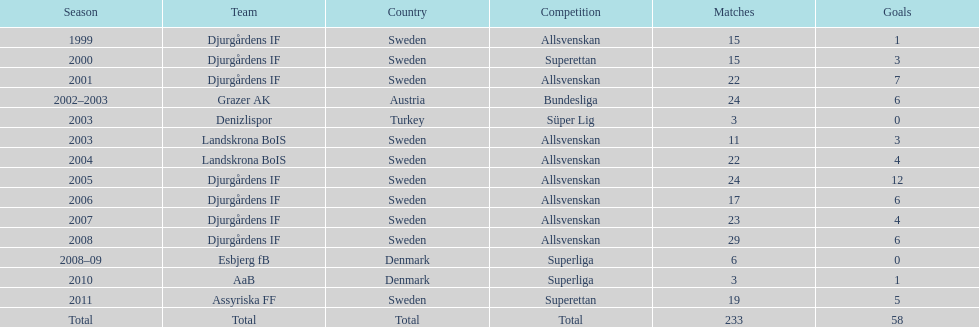How many total goals has jones kusi-asare scored? 58. 